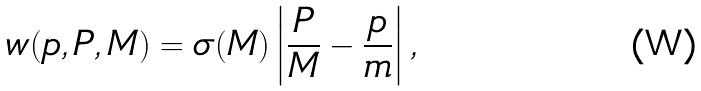Convert formula to latex. <formula><loc_0><loc_0><loc_500><loc_500>w ( { p } , { P } , M ) = \sigma ( M ) \left | \frac { P } { M } - \frac { p } { m } \right | ,</formula> 